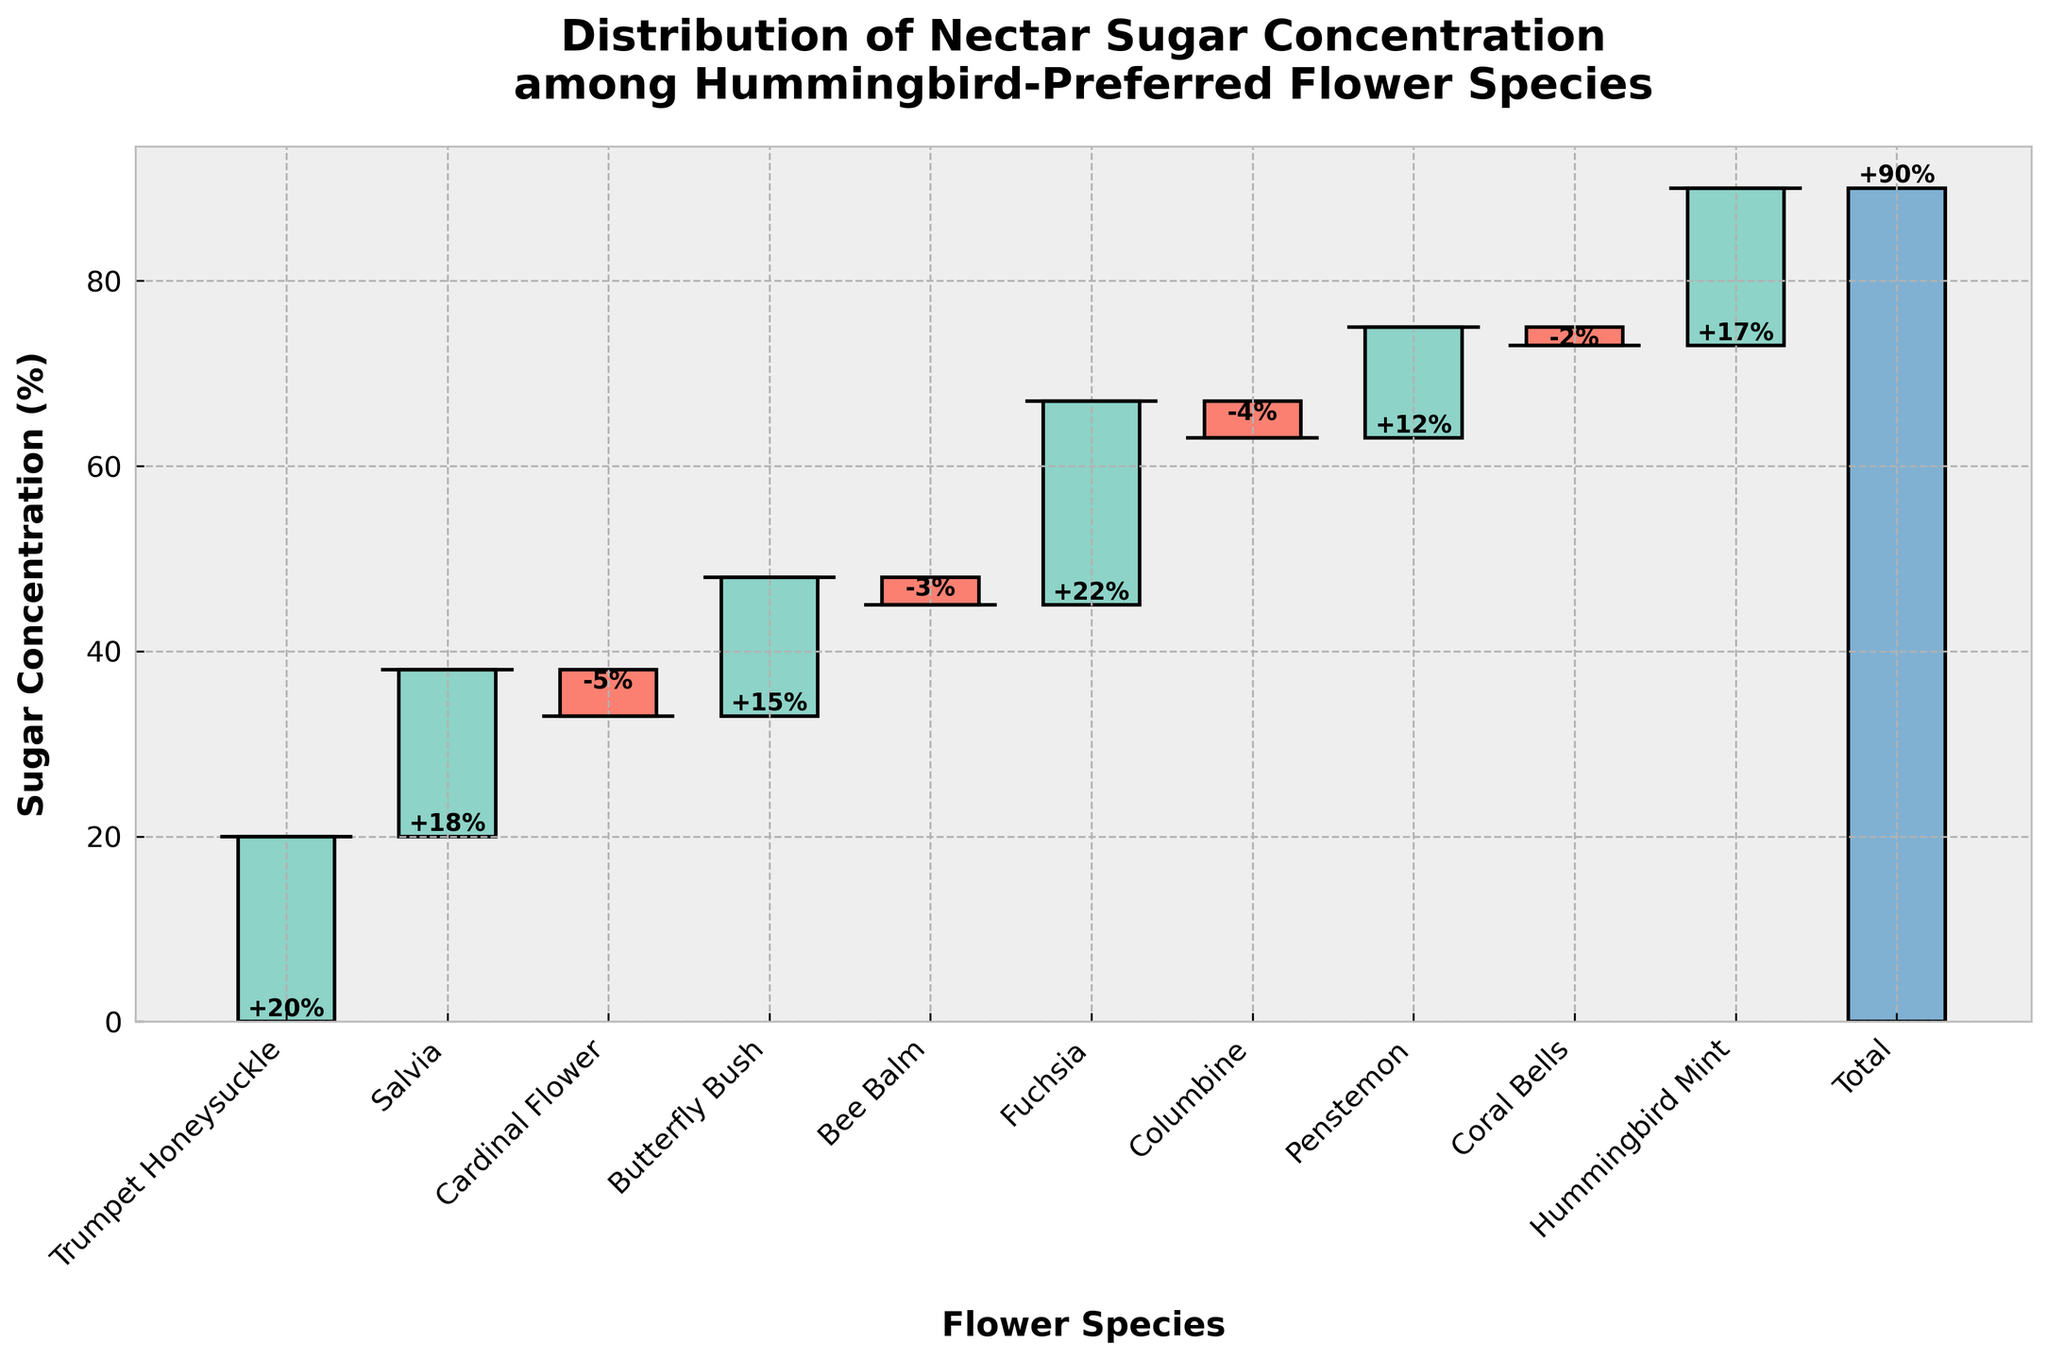What's the average nectar sugar concentration for the flower species excluding the total? The figure displays the sugar concentrations for 10 flower species: 20, 18, -5, 15, -3, 22, -4, 12, -2, 17. Sum them up: 20 + 18 - 5 + 15 - 3 + 22 - 4 + 12 - 2 + 17 = 90. There are 10 species, so the average is 90 / 10 = 9.
Answer: 9% Which flower species has the highest nectar sugar concentration? The tallest bar in the upward direction represents the highest nectar sugar concentration, which is for Fuchsia at 22%.
Answer: Fuchsia How many species have a negative nectar sugar concentration? By examining the bars in the chart, we see four species with downward (negative) bars: Cardinal Flower, Bee Balm, Columbine, and Coral Bells.
Answer: 4 What is the cumulative sugar concentration after adding all positive values? Positive concentrations are: 20 (Trumpet Honeysuckle) + 18 (Salvia) + 15 (Butterfly Bush) + 22 (Fuchsia) + 12 (Penstemon) + 17 (Hummingbird Mint). Sum these values: 20 + 18 + 15 + 22 + 12 + 17 = 104.
Answer: 104 Which species contributes the second-highest positive increment to the total sugar concentration? The second-tallest upward bar represents the second-highest positive increment, which is from Trumpet Honeysuckle at 20%.
Answer: Trumpet Honeysuckle How does the nectar sugar concentration of Salvia compare to that of Butterfly Bush? Compare the heights of the bars for Salvia and Butterfly Bush. Salvia has a nectar sugar concentration of 18%, while Butterfly Bush has 15%. Thus, Salvia's concentration is greater.
Answer: Salvia > Butterfly Bush What is the net effect of the flower species with negative nectar sugar concentrations on the total? Negative concentrations are: -5 (Cardinal Flower) - 3 (Bee Balm) - 4 (Columbine) - 2 (Coral Bells). Sum these values: -5 - 3 - 4 - 2 = -14.
Answer: -14 What is the total nectar sugar concentration for all the flower species? The total is explicitly shown in the last bar of the Waterfall Chart, representing an overall sugar concentration of 90%.
Answer: 90 What is the effect of removing Fuchsia on the total nectar sugar concentration? Fuchsia has a concentration of 22%. The total concentration is 90%. Removing Fuchsia gives: 90 - 22 = 68.
Answer: 68 Which species have a nectar sugar concentration below the average concentration? The average concentration is 9%. Species below this are: Cardinal Flower (-5), Bee Balm (-3), Columbine (-4), Coral Bells (-2).
Answer: Cardinal Flower, Bee Balm, Columbine, Coral Bells 